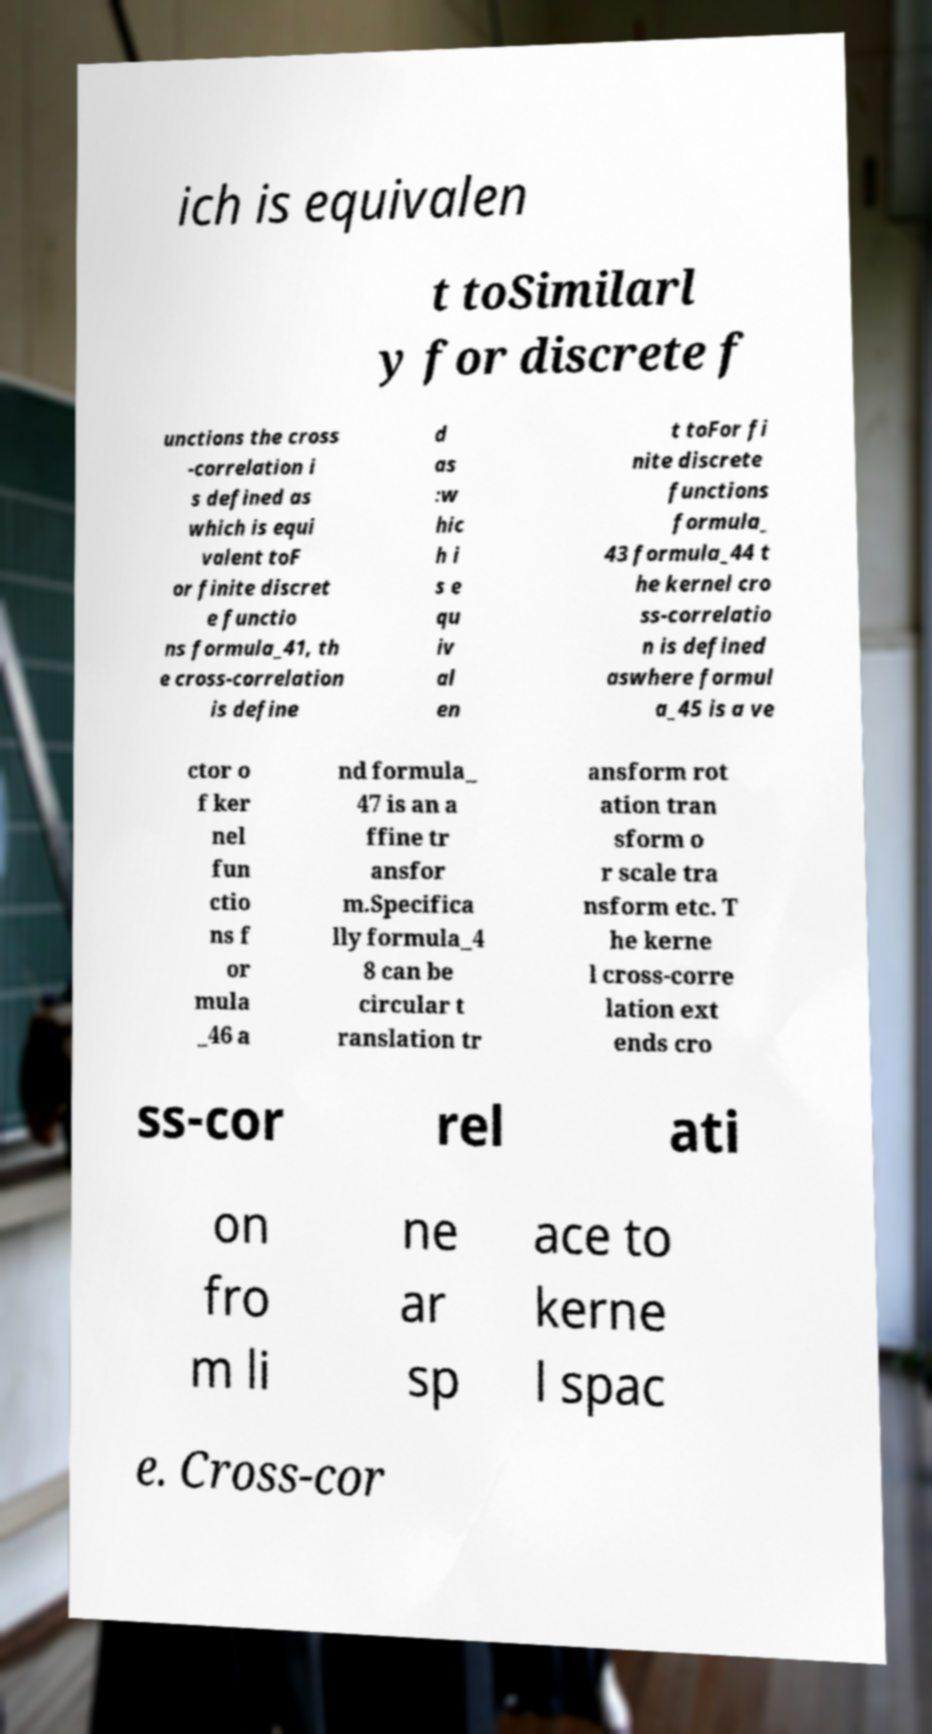Please identify and transcribe the text found in this image. ich is equivalen t toSimilarl y for discrete f unctions the cross -correlation i s defined as which is equi valent toF or finite discret e functio ns formula_41, th e cross-correlation is define d as :w hic h i s e qu iv al en t toFor fi nite discrete functions formula_ 43 formula_44 t he kernel cro ss-correlatio n is defined aswhere formul a_45 is a ve ctor o f ker nel fun ctio ns f or mula _46 a nd formula_ 47 is an a ffine tr ansfor m.Specifica lly formula_4 8 can be circular t ranslation tr ansform rot ation tran sform o r scale tra nsform etc. T he kerne l cross-corre lation ext ends cro ss-cor rel ati on fro m li ne ar sp ace to kerne l spac e. Cross-cor 